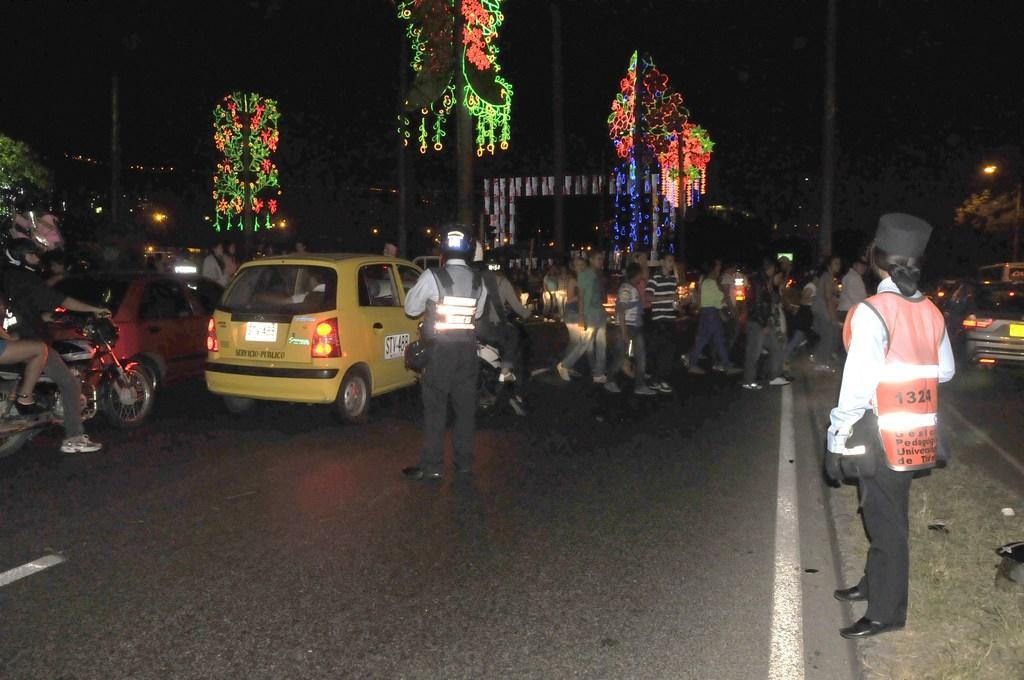Please provide a concise description of this image. The photo is taken on a road. Few people are crossing the road. Few vehicles are passing by the road. In the background there are lights attached to poles. In the right a lady wearing a safety jacket and cap is standing. 